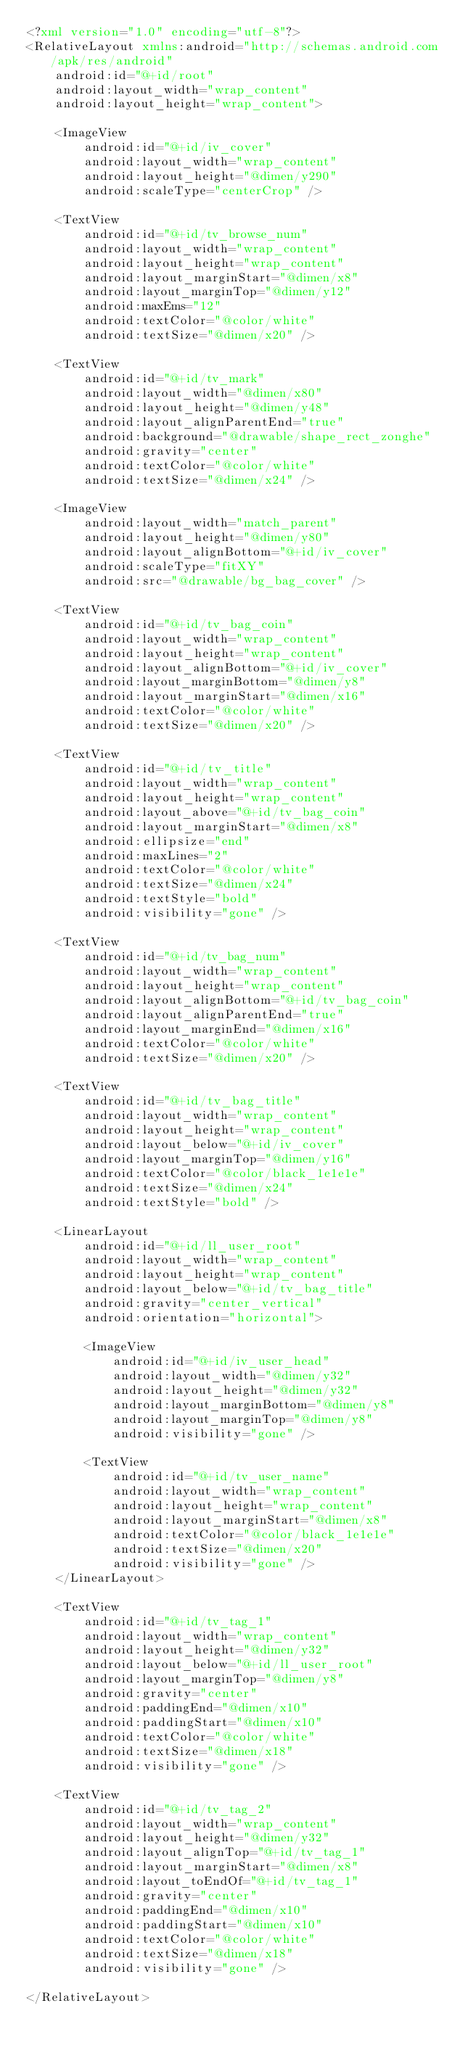<code> <loc_0><loc_0><loc_500><loc_500><_XML_><?xml version="1.0" encoding="utf-8"?>
<RelativeLayout xmlns:android="http://schemas.android.com/apk/res/android"
    android:id="@+id/root"
    android:layout_width="wrap_content"
    android:layout_height="wrap_content">

    <ImageView
        android:id="@+id/iv_cover"
        android:layout_width="wrap_content"
        android:layout_height="@dimen/y290"
        android:scaleType="centerCrop" />

    <TextView
        android:id="@+id/tv_browse_num"
        android:layout_width="wrap_content"
        android:layout_height="wrap_content"
        android:layout_marginStart="@dimen/x8"
        android:layout_marginTop="@dimen/y12"
        android:maxEms="12"
        android:textColor="@color/white"
        android:textSize="@dimen/x20" />

    <TextView
        android:id="@+id/tv_mark"
        android:layout_width="@dimen/x80"
        android:layout_height="@dimen/y48"
        android:layout_alignParentEnd="true"
        android:background="@drawable/shape_rect_zonghe"
        android:gravity="center"
        android:textColor="@color/white"
        android:textSize="@dimen/x24" />

    <ImageView
        android:layout_width="match_parent"
        android:layout_height="@dimen/y80"
        android:layout_alignBottom="@+id/iv_cover"
        android:scaleType="fitXY"
        android:src="@drawable/bg_bag_cover" />

    <TextView
        android:id="@+id/tv_bag_coin"
        android:layout_width="wrap_content"
        android:layout_height="wrap_content"
        android:layout_alignBottom="@+id/iv_cover"
        android:layout_marginBottom="@dimen/y8"
        android:layout_marginStart="@dimen/x16"
        android:textColor="@color/white"
        android:textSize="@dimen/x20" />

    <TextView
        android:id="@+id/tv_title"
        android:layout_width="wrap_content"
        android:layout_height="wrap_content"
        android:layout_above="@+id/tv_bag_coin"
        android:layout_marginStart="@dimen/x8"
        android:ellipsize="end"
        android:maxLines="2"
        android:textColor="@color/white"
        android:textSize="@dimen/x24"
        android:textStyle="bold"
        android:visibility="gone" />

    <TextView
        android:id="@+id/tv_bag_num"
        android:layout_width="wrap_content"
        android:layout_height="wrap_content"
        android:layout_alignBottom="@+id/tv_bag_coin"
        android:layout_alignParentEnd="true"
        android:layout_marginEnd="@dimen/x16"
        android:textColor="@color/white"
        android:textSize="@dimen/x20" />

    <TextView
        android:id="@+id/tv_bag_title"
        android:layout_width="wrap_content"
        android:layout_height="wrap_content"
        android:layout_below="@+id/iv_cover"
        android:layout_marginTop="@dimen/y16"
        android:textColor="@color/black_1e1e1e"
        android:textSize="@dimen/x24"
        android:textStyle="bold" />

    <LinearLayout
        android:id="@+id/ll_user_root"
        android:layout_width="wrap_content"
        android:layout_height="wrap_content"
        android:layout_below="@+id/tv_bag_title"
        android:gravity="center_vertical"
        android:orientation="horizontal">

        <ImageView
            android:id="@+id/iv_user_head"
            android:layout_width="@dimen/y32"
            android:layout_height="@dimen/y32"
            android:layout_marginBottom="@dimen/y8"
            android:layout_marginTop="@dimen/y8"
            android:visibility="gone" />

        <TextView
            android:id="@+id/tv_user_name"
            android:layout_width="wrap_content"
            android:layout_height="wrap_content"
            android:layout_marginStart="@dimen/x8"
            android:textColor="@color/black_1e1e1e"
            android:textSize="@dimen/x20"
            android:visibility="gone" />
    </LinearLayout>

    <TextView
        android:id="@+id/tv_tag_1"
        android:layout_width="wrap_content"
        android:layout_height="@dimen/y32"
        android:layout_below="@+id/ll_user_root"
        android:layout_marginTop="@dimen/y8"
        android:gravity="center"
        android:paddingEnd="@dimen/x10"
        android:paddingStart="@dimen/x10"
        android:textColor="@color/white"
        android:textSize="@dimen/x18"
        android:visibility="gone" />

    <TextView
        android:id="@+id/tv_tag_2"
        android:layout_width="wrap_content"
        android:layout_height="@dimen/y32"
        android:layout_alignTop="@+id/tv_tag_1"
        android:layout_marginStart="@dimen/x8"
        android:layout_toEndOf="@+id/tv_tag_1"
        android:gravity="center"
        android:paddingEnd="@dimen/x10"
        android:paddingStart="@dimen/x10"
        android:textColor="@color/white"
        android:textSize="@dimen/x18"
        android:visibility="gone" />

</RelativeLayout></code> 